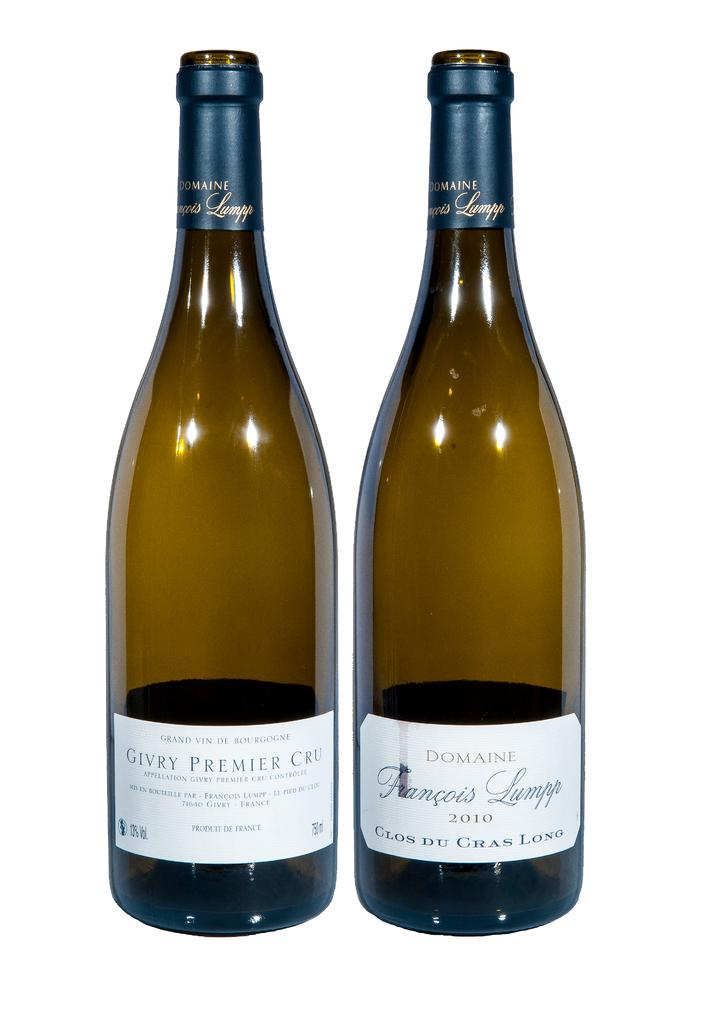How many bottles are visible in the image? There are two bottles in the image. What can be found on the bottles? There are labels attached to the bottles. What information is provided on the labels? There is text written on the labels. What is the color of the background in the image? The background of the image is white. How does the snow affect the control of the bottles in the image? There is no snow present in the image, so it does not affect the control of the bottles. Can you describe the haircut of the person holding the bottles in the image? There is no person holding the bottles in the image, so it is not possible to describe their haircut. 